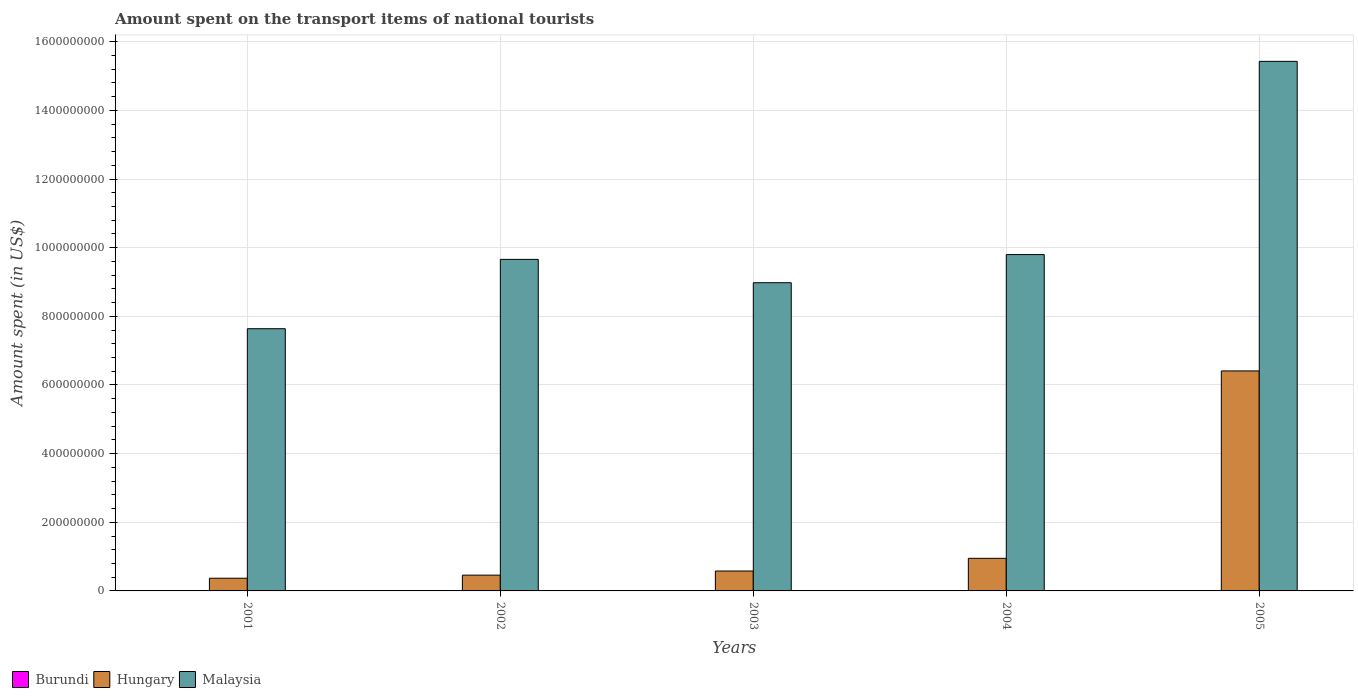Are the number of bars per tick equal to the number of legend labels?
Your response must be concise. Yes. Are the number of bars on each tick of the X-axis equal?
Ensure brevity in your answer.  Yes. How many bars are there on the 3rd tick from the right?
Make the answer very short. 3. What is the label of the 2nd group of bars from the left?
Give a very brief answer. 2002. In which year was the amount spent on the transport items of national tourists in Burundi maximum?
Make the answer very short. 2004. What is the total amount spent on the transport items of national tourists in Malaysia in the graph?
Provide a short and direct response. 5.15e+09. What is the difference between the amount spent on the transport items of national tourists in Burundi in 2003 and the amount spent on the transport items of national tourists in Malaysia in 2002?
Provide a succinct answer. -9.66e+08. What is the average amount spent on the transport items of national tourists in Malaysia per year?
Your response must be concise. 1.03e+09. In the year 2004, what is the difference between the amount spent on the transport items of national tourists in Hungary and amount spent on the transport items of national tourists in Burundi?
Your response must be concise. 9.44e+07. What is the ratio of the amount spent on the transport items of national tourists in Hungary in 2002 to that in 2005?
Offer a very short reply. 0.07. Is the amount spent on the transport items of national tourists in Burundi in 2004 less than that in 2005?
Offer a very short reply. No. What is the difference between the highest and the second highest amount spent on the transport items of national tourists in Malaysia?
Offer a terse response. 5.63e+08. What is the difference between the highest and the lowest amount spent on the transport items of national tourists in Hungary?
Your answer should be very brief. 6.04e+08. In how many years, is the amount spent on the transport items of national tourists in Malaysia greater than the average amount spent on the transport items of national tourists in Malaysia taken over all years?
Your answer should be compact. 1. What does the 1st bar from the left in 2002 represents?
Your answer should be very brief. Burundi. What does the 1st bar from the right in 2002 represents?
Ensure brevity in your answer.  Malaysia. Is it the case that in every year, the sum of the amount spent on the transport items of national tourists in Burundi and amount spent on the transport items of national tourists in Malaysia is greater than the amount spent on the transport items of national tourists in Hungary?
Provide a succinct answer. Yes. How many bars are there?
Offer a terse response. 15. Are all the bars in the graph horizontal?
Your response must be concise. No. Are the values on the major ticks of Y-axis written in scientific E-notation?
Provide a succinct answer. No. Does the graph contain any zero values?
Give a very brief answer. No. Does the graph contain grids?
Your response must be concise. Yes. Where does the legend appear in the graph?
Keep it short and to the point. Bottom left. How many legend labels are there?
Make the answer very short. 3. How are the legend labels stacked?
Ensure brevity in your answer.  Horizontal. What is the title of the graph?
Your answer should be compact. Amount spent on the transport items of national tourists. What is the label or title of the X-axis?
Ensure brevity in your answer.  Years. What is the label or title of the Y-axis?
Provide a succinct answer. Amount spent (in US$). What is the Amount spent (in US$) of Burundi in 2001?
Your answer should be very brief. 4.00e+05. What is the Amount spent (in US$) in Hungary in 2001?
Offer a terse response. 3.70e+07. What is the Amount spent (in US$) in Malaysia in 2001?
Your response must be concise. 7.64e+08. What is the Amount spent (in US$) in Hungary in 2002?
Keep it short and to the point. 4.60e+07. What is the Amount spent (in US$) in Malaysia in 2002?
Give a very brief answer. 9.66e+08. What is the Amount spent (in US$) of Hungary in 2003?
Give a very brief answer. 5.80e+07. What is the Amount spent (in US$) of Malaysia in 2003?
Ensure brevity in your answer.  8.98e+08. What is the Amount spent (in US$) of Burundi in 2004?
Make the answer very short. 6.00e+05. What is the Amount spent (in US$) in Hungary in 2004?
Ensure brevity in your answer.  9.50e+07. What is the Amount spent (in US$) of Malaysia in 2004?
Offer a terse response. 9.80e+08. What is the Amount spent (in US$) in Burundi in 2005?
Give a very brief answer. 4.00e+05. What is the Amount spent (in US$) in Hungary in 2005?
Your answer should be compact. 6.41e+08. What is the Amount spent (in US$) in Malaysia in 2005?
Your response must be concise. 1.54e+09. Across all years, what is the maximum Amount spent (in US$) of Hungary?
Provide a succinct answer. 6.41e+08. Across all years, what is the maximum Amount spent (in US$) in Malaysia?
Give a very brief answer. 1.54e+09. Across all years, what is the minimum Amount spent (in US$) of Hungary?
Make the answer very short. 3.70e+07. Across all years, what is the minimum Amount spent (in US$) of Malaysia?
Your answer should be compact. 7.64e+08. What is the total Amount spent (in US$) in Burundi in the graph?
Ensure brevity in your answer.  2.40e+06. What is the total Amount spent (in US$) in Hungary in the graph?
Give a very brief answer. 8.77e+08. What is the total Amount spent (in US$) of Malaysia in the graph?
Ensure brevity in your answer.  5.15e+09. What is the difference between the Amount spent (in US$) in Burundi in 2001 and that in 2002?
Provide a short and direct response. -1.00e+05. What is the difference between the Amount spent (in US$) of Hungary in 2001 and that in 2002?
Give a very brief answer. -9.00e+06. What is the difference between the Amount spent (in US$) of Malaysia in 2001 and that in 2002?
Your response must be concise. -2.02e+08. What is the difference between the Amount spent (in US$) in Burundi in 2001 and that in 2003?
Provide a succinct answer. -1.00e+05. What is the difference between the Amount spent (in US$) in Hungary in 2001 and that in 2003?
Offer a very short reply. -2.10e+07. What is the difference between the Amount spent (in US$) of Malaysia in 2001 and that in 2003?
Offer a terse response. -1.34e+08. What is the difference between the Amount spent (in US$) in Hungary in 2001 and that in 2004?
Your answer should be compact. -5.80e+07. What is the difference between the Amount spent (in US$) in Malaysia in 2001 and that in 2004?
Your answer should be compact. -2.16e+08. What is the difference between the Amount spent (in US$) in Hungary in 2001 and that in 2005?
Make the answer very short. -6.04e+08. What is the difference between the Amount spent (in US$) of Malaysia in 2001 and that in 2005?
Provide a short and direct response. -7.79e+08. What is the difference between the Amount spent (in US$) of Hungary in 2002 and that in 2003?
Provide a short and direct response. -1.20e+07. What is the difference between the Amount spent (in US$) in Malaysia in 2002 and that in 2003?
Provide a succinct answer. 6.80e+07. What is the difference between the Amount spent (in US$) of Hungary in 2002 and that in 2004?
Offer a terse response. -4.90e+07. What is the difference between the Amount spent (in US$) in Malaysia in 2002 and that in 2004?
Provide a succinct answer. -1.40e+07. What is the difference between the Amount spent (in US$) in Hungary in 2002 and that in 2005?
Your answer should be compact. -5.95e+08. What is the difference between the Amount spent (in US$) of Malaysia in 2002 and that in 2005?
Make the answer very short. -5.77e+08. What is the difference between the Amount spent (in US$) in Hungary in 2003 and that in 2004?
Your answer should be very brief. -3.70e+07. What is the difference between the Amount spent (in US$) in Malaysia in 2003 and that in 2004?
Your answer should be compact. -8.20e+07. What is the difference between the Amount spent (in US$) in Hungary in 2003 and that in 2005?
Keep it short and to the point. -5.83e+08. What is the difference between the Amount spent (in US$) in Malaysia in 2003 and that in 2005?
Offer a very short reply. -6.45e+08. What is the difference between the Amount spent (in US$) in Hungary in 2004 and that in 2005?
Make the answer very short. -5.46e+08. What is the difference between the Amount spent (in US$) of Malaysia in 2004 and that in 2005?
Make the answer very short. -5.63e+08. What is the difference between the Amount spent (in US$) of Burundi in 2001 and the Amount spent (in US$) of Hungary in 2002?
Keep it short and to the point. -4.56e+07. What is the difference between the Amount spent (in US$) of Burundi in 2001 and the Amount spent (in US$) of Malaysia in 2002?
Offer a very short reply. -9.66e+08. What is the difference between the Amount spent (in US$) in Hungary in 2001 and the Amount spent (in US$) in Malaysia in 2002?
Make the answer very short. -9.29e+08. What is the difference between the Amount spent (in US$) in Burundi in 2001 and the Amount spent (in US$) in Hungary in 2003?
Your answer should be very brief. -5.76e+07. What is the difference between the Amount spent (in US$) of Burundi in 2001 and the Amount spent (in US$) of Malaysia in 2003?
Make the answer very short. -8.98e+08. What is the difference between the Amount spent (in US$) of Hungary in 2001 and the Amount spent (in US$) of Malaysia in 2003?
Your response must be concise. -8.61e+08. What is the difference between the Amount spent (in US$) of Burundi in 2001 and the Amount spent (in US$) of Hungary in 2004?
Your answer should be compact. -9.46e+07. What is the difference between the Amount spent (in US$) of Burundi in 2001 and the Amount spent (in US$) of Malaysia in 2004?
Your response must be concise. -9.80e+08. What is the difference between the Amount spent (in US$) of Hungary in 2001 and the Amount spent (in US$) of Malaysia in 2004?
Make the answer very short. -9.43e+08. What is the difference between the Amount spent (in US$) of Burundi in 2001 and the Amount spent (in US$) of Hungary in 2005?
Provide a short and direct response. -6.41e+08. What is the difference between the Amount spent (in US$) of Burundi in 2001 and the Amount spent (in US$) of Malaysia in 2005?
Your answer should be compact. -1.54e+09. What is the difference between the Amount spent (in US$) of Hungary in 2001 and the Amount spent (in US$) of Malaysia in 2005?
Your response must be concise. -1.51e+09. What is the difference between the Amount spent (in US$) of Burundi in 2002 and the Amount spent (in US$) of Hungary in 2003?
Provide a succinct answer. -5.75e+07. What is the difference between the Amount spent (in US$) of Burundi in 2002 and the Amount spent (in US$) of Malaysia in 2003?
Your response must be concise. -8.98e+08. What is the difference between the Amount spent (in US$) of Hungary in 2002 and the Amount spent (in US$) of Malaysia in 2003?
Your response must be concise. -8.52e+08. What is the difference between the Amount spent (in US$) of Burundi in 2002 and the Amount spent (in US$) of Hungary in 2004?
Make the answer very short. -9.45e+07. What is the difference between the Amount spent (in US$) of Burundi in 2002 and the Amount spent (in US$) of Malaysia in 2004?
Offer a terse response. -9.80e+08. What is the difference between the Amount spent (in US$) of Hungary in 2002 and the Amount spent (in US$) of Malaysia in 2004?
Your response must be concise. -9.34e+08. What is the difference between the Amount spent (in US$) of Burundi in 2002 and the Amount spent (in US$) of Hungary in 2005?
Make the answer very short. -6.40e+08. What is the difference between the Amount spent (in US$) of Burundi in 2002 and the Amount spent (in US$) of Malaysia in 2005?
Offer a terse response. -1.54e+09. What is the difference between the Amount spent (in US$) in Hungary in 2002 and the Amount spent (in US$) in Malaysia in 2005?
Provide a succinct answer. -1.50e+09. What is the difference between the Amount spent (in US$) in Burundi in 2003 and the Amount spent (in US$) in Hungary in 2004?
Provide a succinct answer. -9.45e+07. What is the difference between the Amount spent (in US$) of Burundi in 2003 and the Amount spent (in US$) of Malaysia in 2004?
Ensure brevity in your answer.  -9.80e+08. What is the difference between the Amount spent (in US$) of Hungary in 2003 and the Amount spent (in US$) of Malaysia in 2004?
Offer a very short reply. -9.22e+08. What is the difference between the Amount spent (in US$) in Burundi in 2003 and the Amount spent (in US$) in Hungary in 2005?
Provide a short and direct response. -6.40e+08. What is the difference between the Amount spent (in US$) in Burundi in 2003 and the Amount spent (in US$) in Malaysia in 2005?
Provide a short and direct response. -1.54e+09. What is the difference between the Amount spent (in US$) in Hungary in 2003 and the Amount spent (in US$) in Malaysia in 2005?
Your answer should be compact. -1.48e+09. What is the difference between the Amount spent (in US$) in Burundi in 2004 and the Amount spent (in US$) in Hungary in 2005?
Provide a short and direct response. -6.40e+08. What is the difference between the Amount spent (in US$) of Burundi in 2004 and the Amount spent (in US$) of Malaysia in 2005?
Provide a succinct answer. -1.54e+09. What is the difference between the Amount spent (in US$) in Hungary in 2004 and the Amount spent (in US$) in Malaysia in 2005?
Your answer should be very brief. -1.45e+09. What is the average Amount spent (in US$) in Hungary per year?
Provide a short and direct response. 1.75e+08. What is the average Amount spent (in US$) of Malaysia per year?
Keep it short and to the point. 1.03e+09. In the year 2001, what is the difference between the Amount spent (in US$) of Burundi and Amount spent (in US$) of Hungary?
Your answer should be very brief. -3.66e+07. In the year 2001, what is the difference between the Amount spent (in US$) of Burundi and Amount spent (in US$) of Malaysia?
Provide a short and direct response. -7.64e+08. In the year 2001, what is the difference between the Amount spent (in US$) in Hungary and Amount spent (in US$) in Malaysia?
Make the answer very short. -7.27e+08. In the year 2002, what is the difference between the Amount spent (in US$) in Burundi and Amount spent (in US$) in Hungary?
Your answer should be compact. -4.55e+07. In the year 2002, what is the difference between the Amount spent (in US$) of Burundi and Amount spent (in US$) of Malaysia?
Offer a terse response. -9.66e+08. In the year 2002, what is the difference between the Amount spent (in US$) of Hungary and Amount spent (in US$) of Malaysia?
Keep it short and to the point. -9.20e+08. In the year 2003, what is the difference between the Amount spent (in US$) of Burundi and Amount spent (in US$) of Hungary?
Give a very brief answer. -5.75e+07. In the year 2003, what is the difference between the Amount spent (in US$) in Burundi and Amount spent (in US$) in Malaysia?
Provide a succinct answer. -8.98e+08. In the year 2003, what is the difference between the Amount spent (in US$) of Hungary and Amount spent (in US$) of Malaysia?
Your response must be concise. -8.40e+08. In the year 2004, what is the difference between the Amount spent (in US$) in Burundi and Amount spent (in US$) in Hungary?
Keep it short and to the point. -9.44e+07. In the year 2004, what is the difference between the Amount spent (in US$) in Burundi and Amount spent (in US$) in Malaysia?
Your answer should be very brief. -9.79e+08. In the year 2004, what is the difference between the Amount spent (in US$) of Hungary and Amount spent (in US$) of Malaysia?
Make the answer very short. -8.85e+08. In the year 2005, what is the difference between the Amount spent (in US$) of Burundi and Amount spent (in US$) of Hungary?
Your response must be concise. -6.41e+08. In the year 2005, what is the difference between the Amount spent (in US$) in Burundi and Amount spent (in US$) in Malaysia?
Offer a terse response. -1.54e+09. In the year 2005, what is the difference between the Amount spent (in US$) of Hungary and Amount spent (in US$) of Malaysia?
Offer a terse response. -9.02e+08. What is the ratio of the Amount spent (in US$) in Hungary in 2001 to that in 2002?
Provide a short and direct response. 0.8. What is the ratio of the Amount spent (in US$) of Malaysia in 2001 to that in 2002?
Your response must be concise. 0.79. What is the ratio of the Amount spent (in US$) of Hungary in 2001 to that in 2003?
Give a very brief answer. 0.64. What is the ratio of the Amount spent (in US$) of Malaysia in 2001 to that in 2003?
Provide a short and direct response. 0.85. What is the ratio of the Amount spent (in US$) of Hungary in 2001 to that in 2004?
Your response must be concise. 0.39. What is the ratio of the Amount spent (in US$) of Malaysia in 2001 to that in 2004?
Provide a short and direct response. 0.78. What is the ratio of the Amount spent (in US$) in Burundi in 2001 to that in 2005?
Make the answer very short. 1. What is the ratio of the Amount spent (in US$) of Hungary in 2001 to that in 2005?
Provide a succinct answer. 0.06. What is the ratio of the Amount spent (in US$) in Malaysia in 2001 to that in 2005?
Give a very brief answer. 0.5. What is the ratio of the Amount spent (in US$) in Hungary in 2002 to that in 2003?
Your response must be concise. 0.79. What is the ratio of the Amount spent (in US$) of Malaysia in 2002 to that in 2003?
Offer a very short reply. 1.08. What is the ratio of the Amount spent (in US$) in Hungary in 2002 to that in 2004?
Provide a short and direct response. 0.48. What is the ratio of the Amount spent (in US$) in Malaysia in 2002 to that in 2004?
Offer a very short reply. 0.99. What is the ratio of the Amount spent (in US$) of Burundi in 2002 to that in 2005?
Make the answer very short. 1.25. What is the ratio of the Amount spent (in US$) of Hungary in 2002 to that in 2005?
Your answer should be very brief. 0.07. What is the ratio of the Amount spent (in US$) in Malaysia in 2002 to that in 2005?
Your response must be concise. 0.63. What is the ratio of the Amount spent (in US$) of Hungary in 2003 to that in 2004?
Provide a succinct answer. 0.61. What is the ratio of the Amount spent (in US$) of Malaysia in 2003 to that in 2004?
Give a very brief answer. 0.92. What is the ratio of the Amount spent (in US$) of Hungary in 2003 to that in 2005?
Keep it short and to the point. 0.09. What is the ratio of the Amount spent (in US$) of Malaysia in 2003 to that in 2005?
Provide a short and direct response. 0.58. What is the ratio of the Amount spent (in US$) of Hungary in 2004 to that in 2005?
Offer a very short reply. 0.15. What is the ratio of the Amount spent (in US$) in Malaysia in 2004 to that in 2005?
Make the answer very short. 0.64. What is the difference between the highest and the second highest Amount spent (in US$) in Burundi?
Provide a short and direct response. 1.00e+05. What is the difference between the highest and the second highest Amount spent (in US$) of Hungary?
Your answer should be very brief. 5.46e+08. What is the difference between the highest and the second highest Amount spent (in US$) of Malaysia?
Offer a very short reply. 5.63e+08. What is the difference between the highest and the lowest Amount spent (in US$) in Burundi?
Provide a succinct answer. 2.00e+05. What is the difference between the highest and the lowest Amount spent (in US$) of Hungary?
Offer a terse response. 6.04e+08. What is the difference between the highest and the lowest Amount spent (in US$) in Malaysia?
Ensure brevity in your answer.  7.79e+08. 